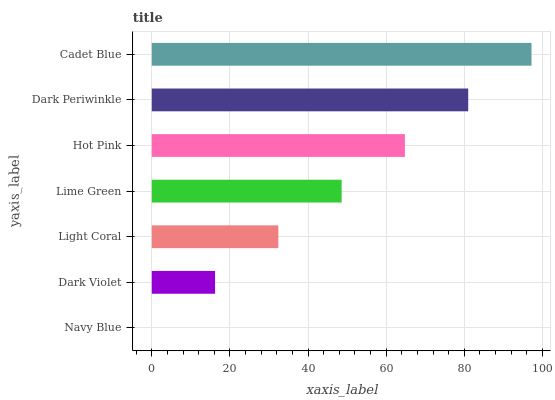Is Navy Blue the minimum?
Answer yes or no. Yes. Is Cadet Blue the maximum?
Answer yes or no. Yes. Is Dark Violet the minimum?
Answer yes or no. No. Is Dark Violet the maximum?
Answer yes or no. No. Is Dark Violet greater than Navy Blue?
Answer yes or no. Yes. Is Navy Blue less than Dark Violet?
Answer yes or no. Yes. Is Navy Blue greater than Dark Violet?
Answer yes or no. No. Is Dark Violet less than Navy Blue?
Answer yes or no. No. Is Lime Green the high median?
Answer yes or no. Yes. Is Lime Green the low median?
Answer yes or no. Yes. Is Dark Violet the high median?
Answer yes or no. No. Is Dark Periwinkle the low median?
Answer yes or no. No. 